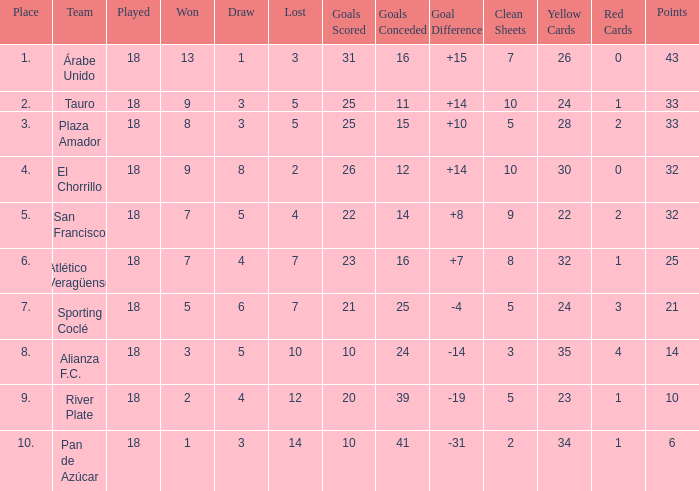How many points did the team have that conceded 41 goals and finish in a place larger than 10? 0.0. 